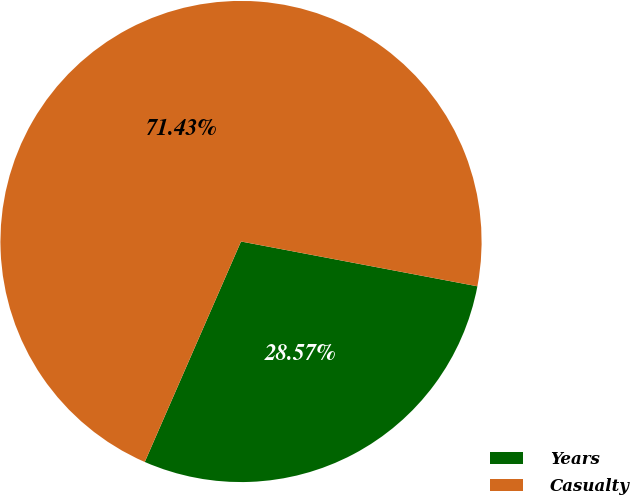Convert chart to OTSL. <chart><loc_0><loc_0><loc_500><loc_500><pie_chart><fcel>Years<fcel>Casualty<nl><fcel>28.57%<fcel>71.43%<nl></chart> 